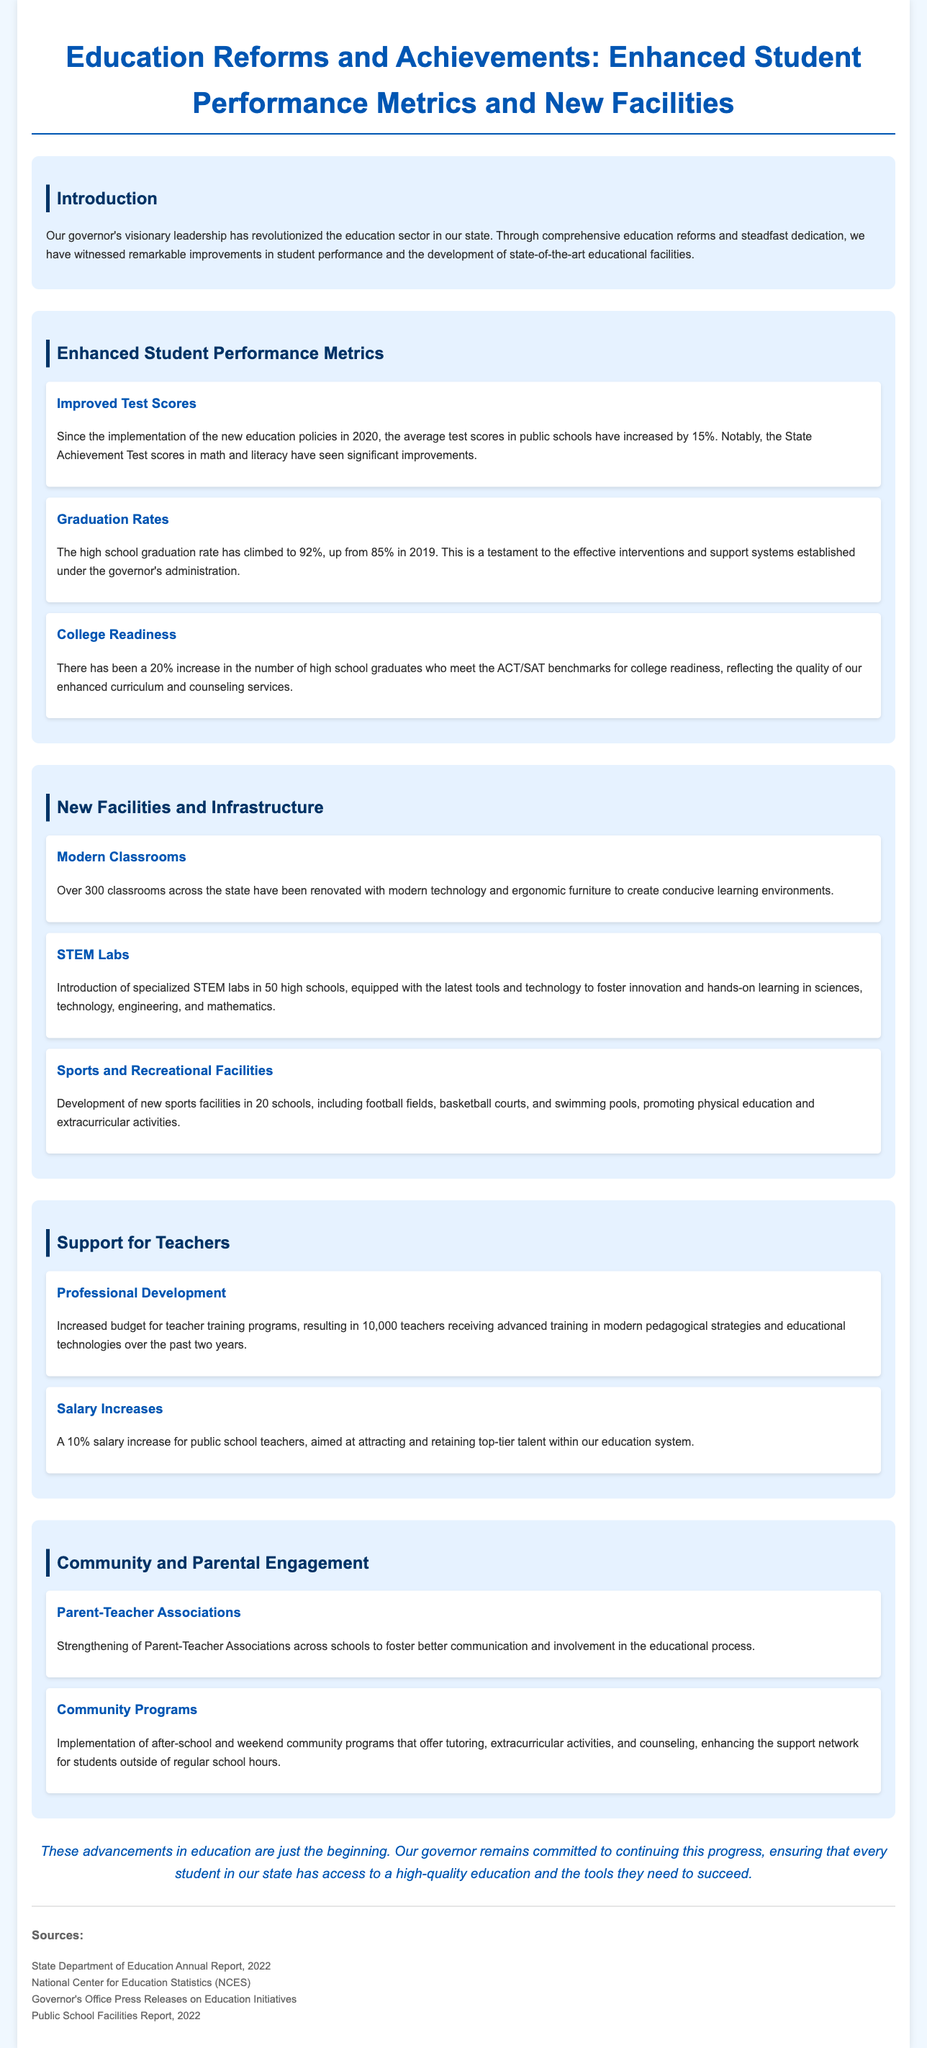What percentage increase did the average test scores see? The document states that the average test scores in public schools have increased by 15%.
Answer: 15% What is the current high school graduation rate? According to the document, the high school graduation rate has climbed to 92%.
Answer: 92% How many classrooms have been renovated? The document indicates that over 300 classrooms across the state have been renovated.
Answer: Over 300 What percentage increase was observed in college readiness for high school graduates? The document reports a 20% increase in the number of high school graduates who meet the ACT/SAT benchmarks.
Answer: 20% How many teachers received advanced training in the past two years? The document notes that 10,000 teachers received advanced training in modern pedagogical strategies.
Answer: 10,000 What is one of the main goals of the education reforms under the governor? The document mentions that the goal is to ensure every student has access to a high-quality education.
Answer: High-quality education Which section discusses the support for teachers? The section labeled "Support for Teachers" covers information about teacher training and salary increases.
Answer: Support for Teachers How many high schools received new STEM labs? The document states that 50 high schools received specialized STEM labs.
Answer: 50 What type of new facilities has been developed in 20 schools? The document mentions new sports facilities such as football fields and basketball courts.
Answer: Sports facilities 